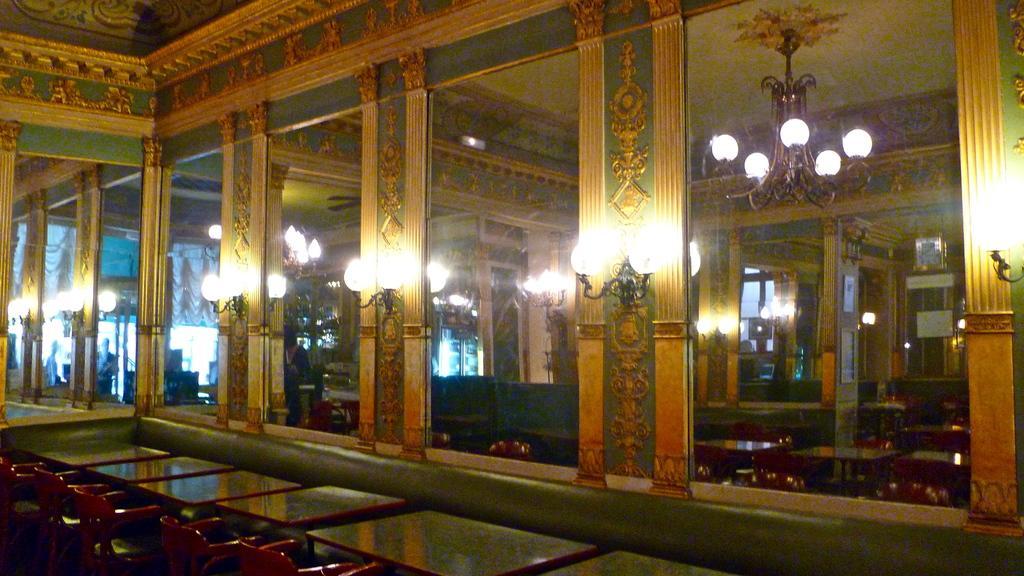Describe this image in one or two sentences. This picture is clicked inside the hall. In the foreground we can see the chairs and tables and we can see the lamps attached to the walls and we can see the chandeliers, roof and mirrors and some other objects. 